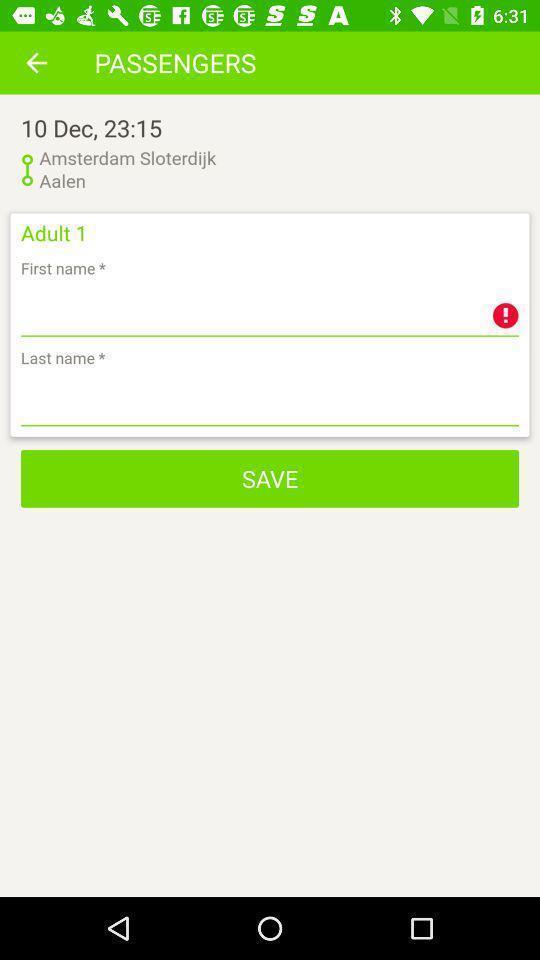Tell me about the visual elements in this screen capture. Page with details of passengers in an travel application. 